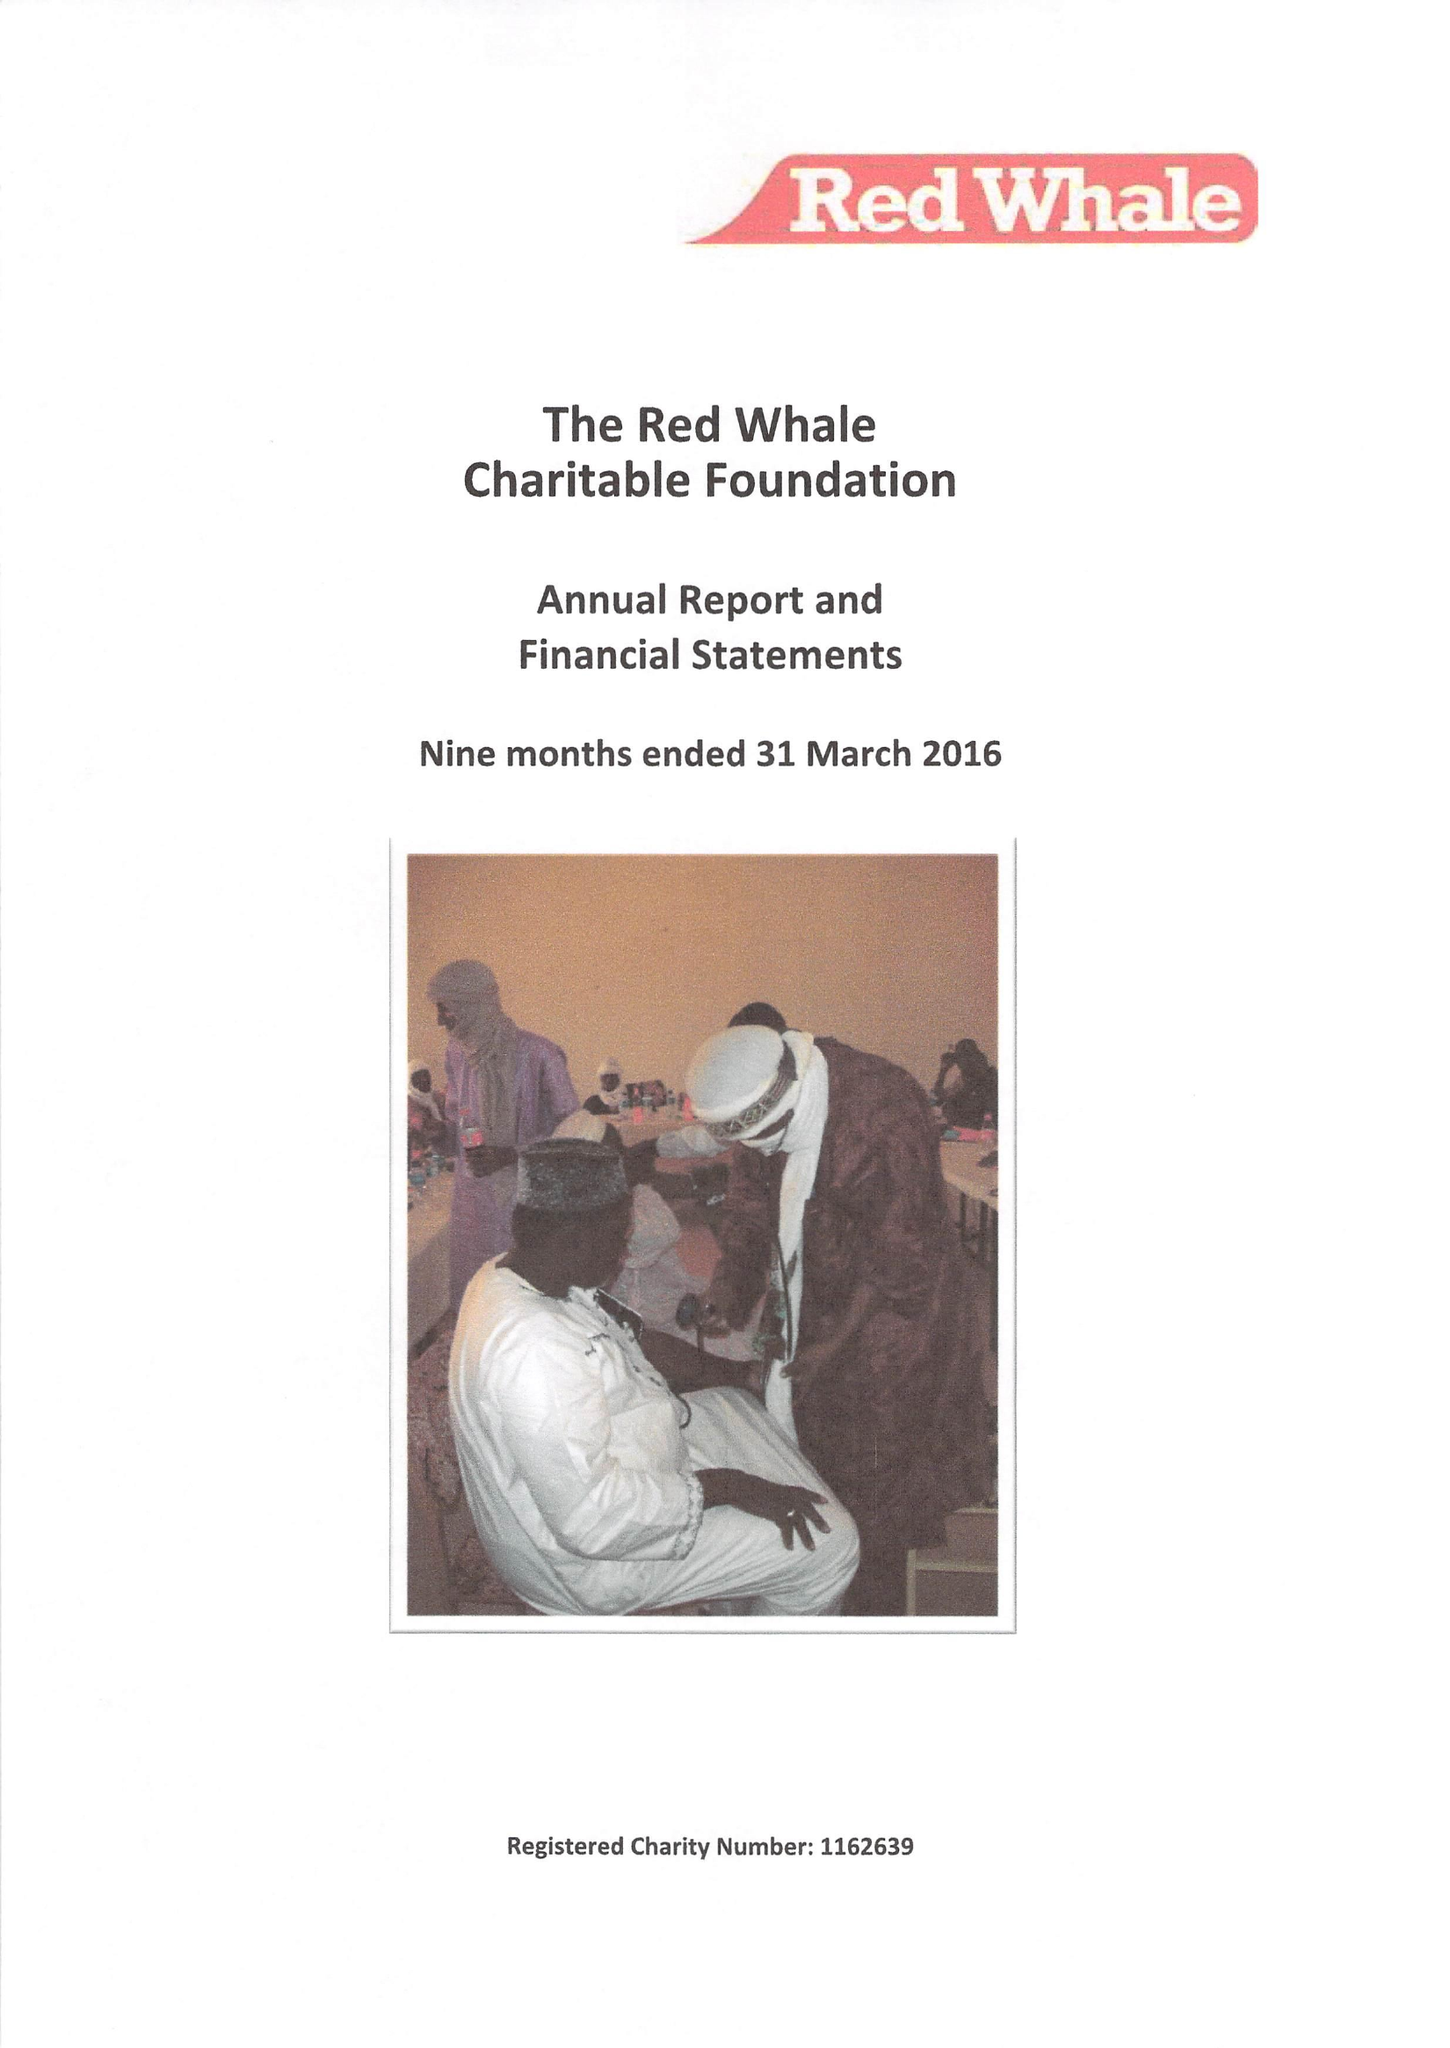What is the value for the report_date?
Answer the question using a single word or phrase. 2016-03-31 